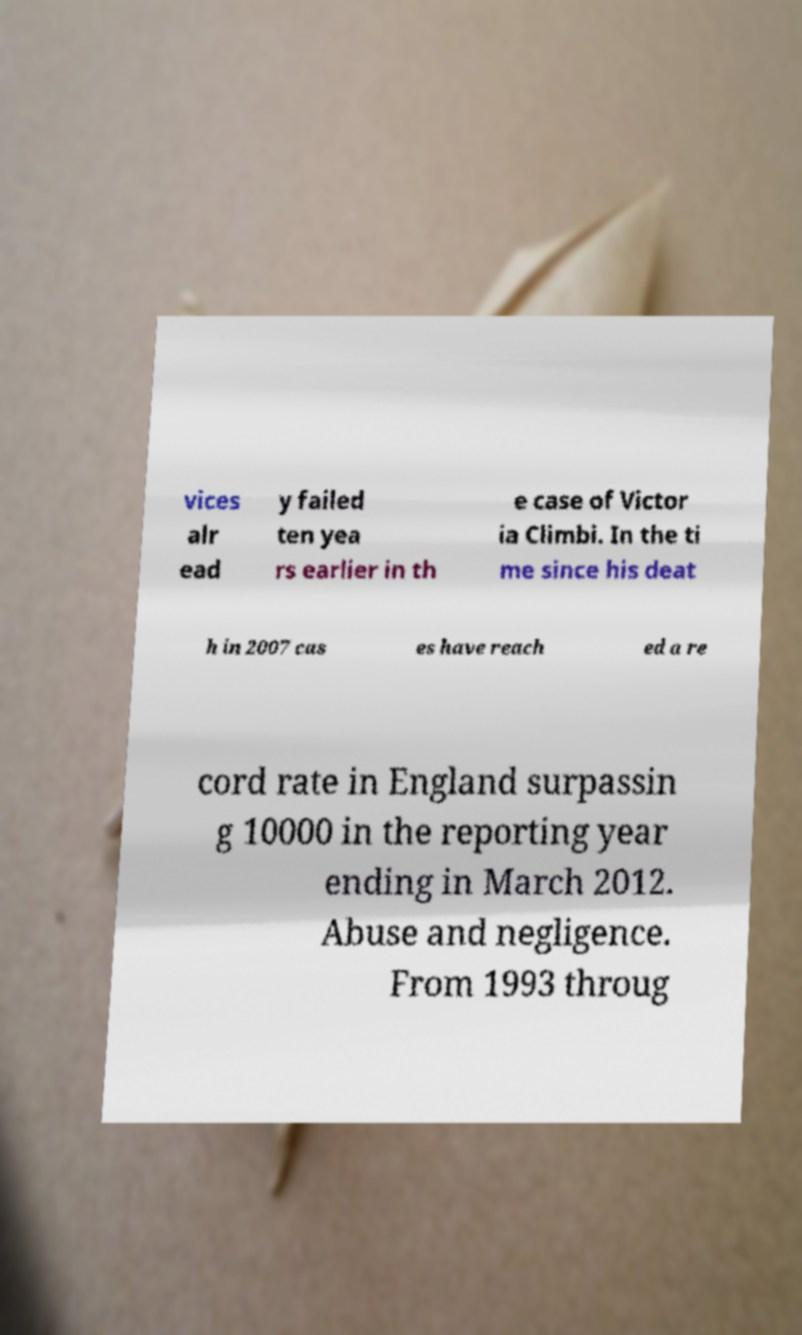Please read and relay the text visible in this image. What does it say? vices alr ead y failed ten yea rs earlier in th e case of Victor ia Climbi. In the ti me since his deat h in 2007 cas es have reach ed a re cord rate in England surpassin g 10000 in the reporting year ending in March 2012. Abuse and negligence. From 1993 throug 